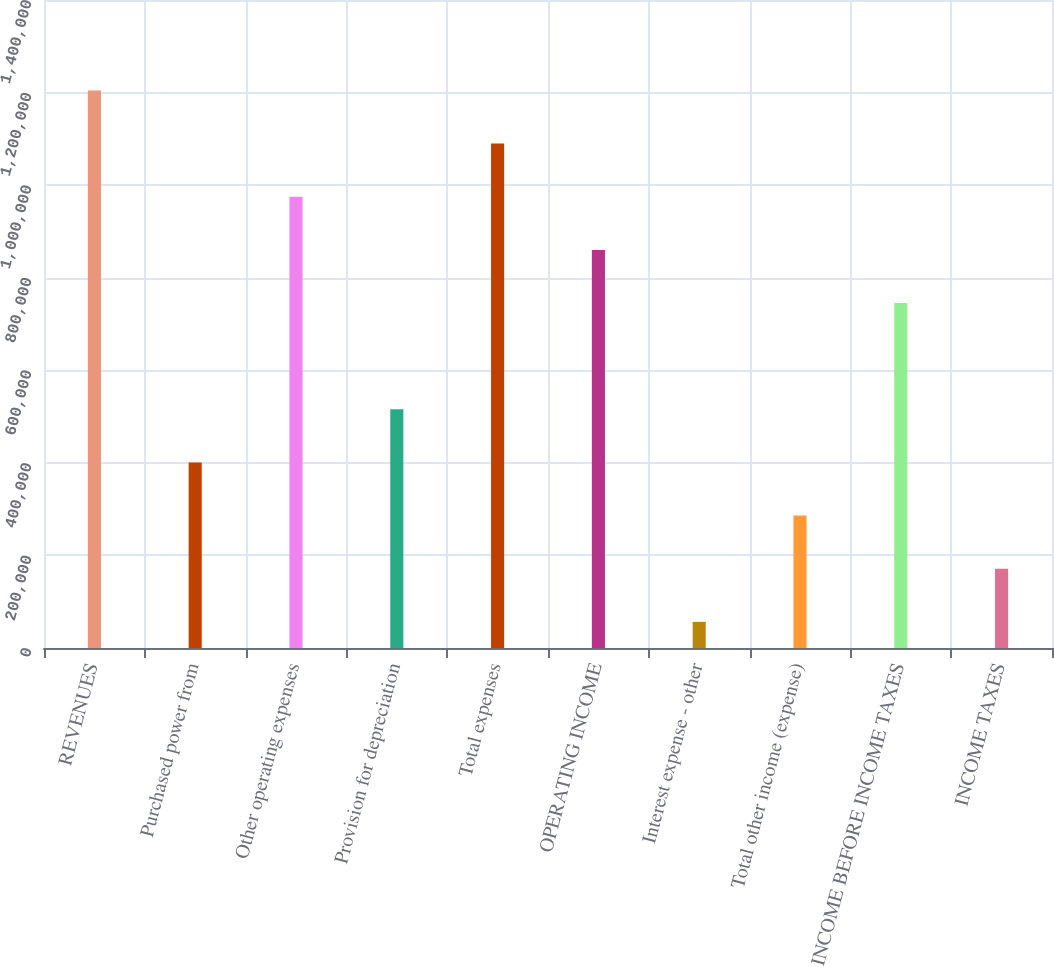<chart> <loc_0><loc_0><loc_500><loc_500><bar_chart><fcel>REVENUES<fcel>Purchased power from<fcel>Other operating expenses<fcel>Provision for depreciation<fcel>Total expenses<fcel>OPERATING INCOME<fcel>Interest expense - other<fcel>Total other income (expense)<fcel>INCOME BEFORE INCOME TAXES<fcel>INCOME TAXES<nl><fcel>1.20453e+06<fcel>400900<fcel>974924<fcel>515705<fcel>1.08973e+06<fcel>860120<fcel>56486<fcel>286096<fcel>745315<fcel>171291<nl></chart> 